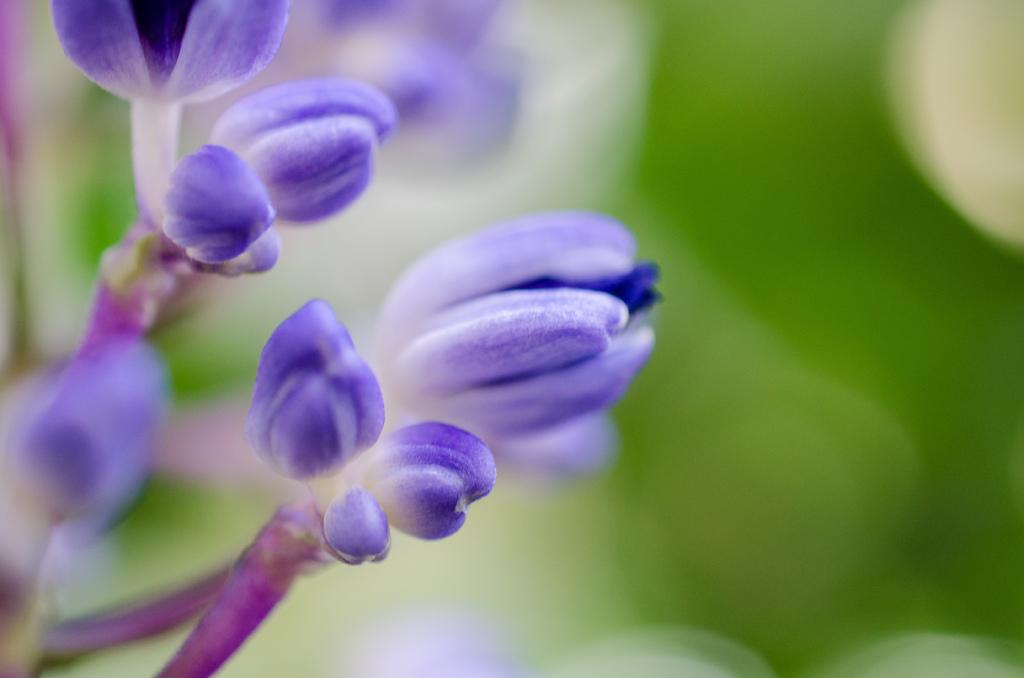What type of plant parts are visible in the image? There are buds and stems in the image. Can you describe the background of the image? The background of the image is blurred. How many ladybugs can be seen on the stems in the image? There are no ladybugs present in the image; it only features buds and stems. 